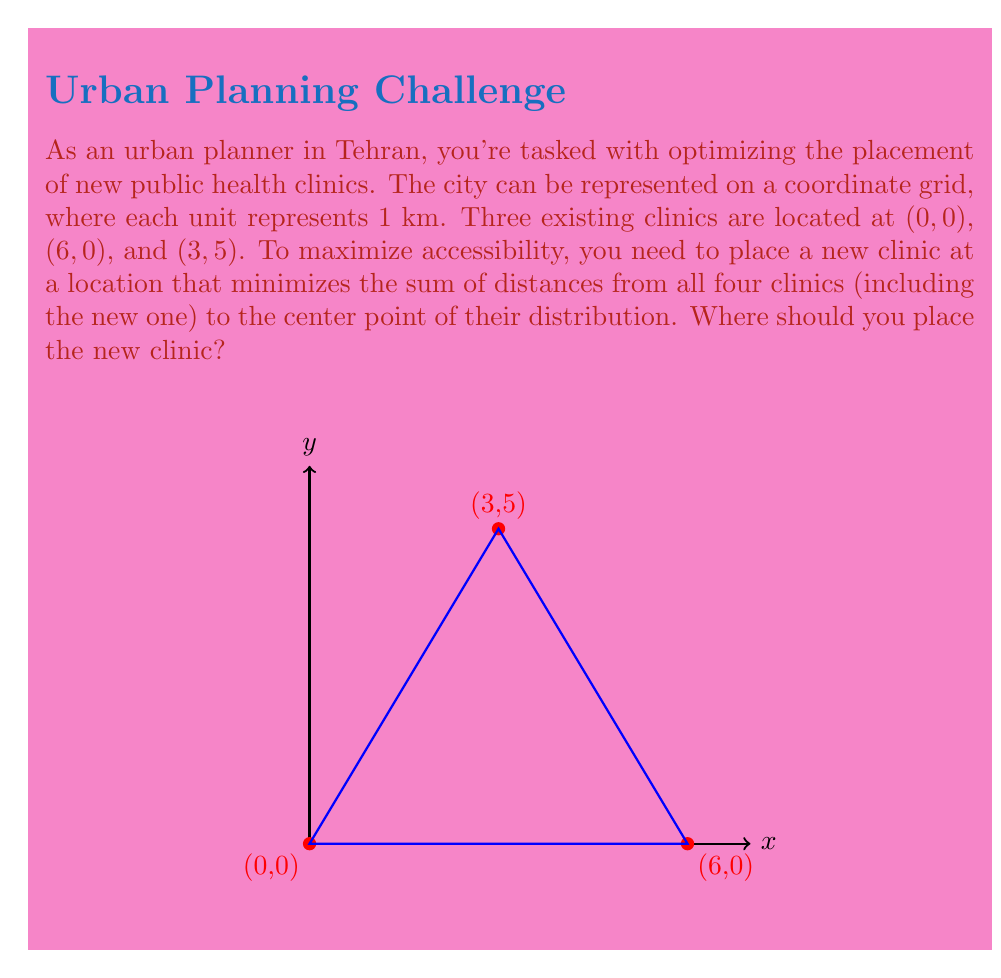Show me your answer to this math problem. Let's approach this step-by-step:

1) First, we need to find the center point of the three existing clinics. The coordinates of this point will be the average of the x-coordinates and y-coordinates:

   $x_c = \frac{0 + 6 + 3}{3} = 3$
   $y_c = \frac{0 + 0 + 5}{3} = \frac{5}{3}$

   So the center point is $(3, \frac{5}{3})$.

2) The optimal location for the new clinic is actually this center point. This is because the center point minimizes the sum of squared distances to all points in a set.

3) To verify this, let's calculate the sum of distances from all four clinics (including the new one) to this center point:

   Distance from (0,0): $\sqrt{(3-0)^2 + (\frac{5}{3}-0)^2} = \sqrt{9 + \frac{25}{9}} = \sqrt{\frac{106}{9}}$
   
   Distance from (6,0): $\sqrt{(3-6)^2 + (\frac{5}{3}-0)^2} = \sqrt{9 + \frac{25}{9}} = \sqrt{\frac{106}{9}}$
   
   Distance from (3,5): $\sqrt{(3-3)^2 + (\frac{5}{3}-5)^2} = \sqrt{0 + \frac{100}{9}} = \frac{10}{3}$
   
   Distance from new clinic (3,5/3) to itself: 0

4) The sum of these distances is:

   $\sqrt{\frac{106}{9}} + \sqrt{\frac{106}{9}} + \frac{10}{3} + 0 = 2\sqrt{\frac{106}{9}} + \frac{10}{3}$

5) Any other location would increase this sum, making it less optimal for overall accessibility.
Answer: $(3, \frac{5}{3})$ 